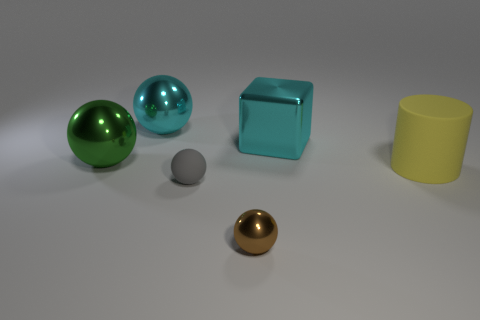The matte cylinder is what color?
Your answer should be very brief. Yellow. How many things are big spheres or tiny matte spheres?
Make the answer very short. 3. What is the material of the gray object that is the same size as the brown object?
Provide a succinct answer. Rubber. How big is the thing that is to the right of the metal block?
Offer a terse response. Large. What is the material of the green thing?
Your answer should be compact. Metal. How many objects are either cyan shiny things that are left of the tiny matte ball or shiny balls that are to the right of the green shiny thing?
Your response must be concise. 2. How many other things are the same color as the large rubber cylinder?
Provide a succinct answer. 0. Is the shape of the gray matte object the same as the shiny thing that is in front of the large yellow object?
Ensure brevity in your answer.  Yes. Is the number of big yellow matte objects that are on the right side of the rubber cylinder less than the number of large metal spheres in front of the gray matte ball?
Your answer should be very brief. No. There is a big cyan object that is the same shape as the green object; what material is it?
Make the answer very short. Metal. 